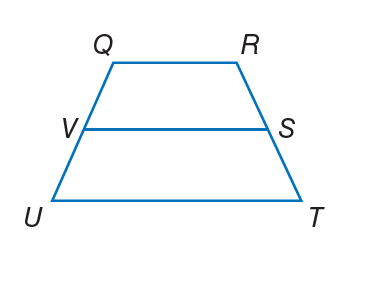Answer the mathemtical geometry problem and directly provide the correct option letter.
Question: For trapezoid Q R T U, V and S are midpoints of the legs. If V S = 9 and U T = 12, find Q R.
Choices: A: 7 B: 17 C: 26 D: 34 A 